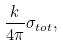Convert formula to latex. <formula><loc_0><loc_0><loc_500><loc_500>\frac { k } { 4 \pi } \sigma _ { t o t } ,</formula> 